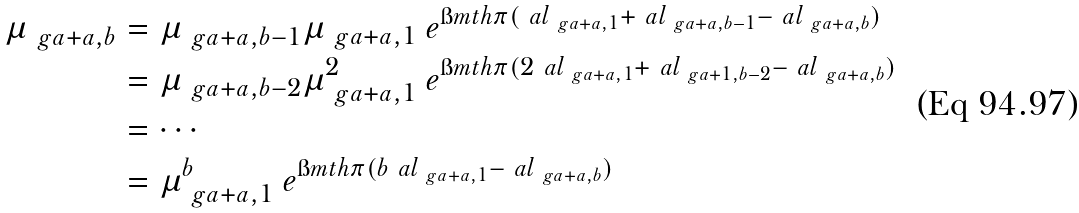Convert formula to latex. <formula><loc_0><loc_0><loc_500><loc_500>\mu _ { \ g a + a , b } & = \mu _ { \ g a + a , b - 1 } \mu _ { \ g a + a , 1 } \ e ^ { \i m t h \pi ( \ a l _ { \ g a + a , 1 } + \ a l _ { \ g a + a , b - 1 } - \ a l _ { \ g a + a , b } ) } \\ & = \mu _ { \ g a + a , b - 2 } \mu ^ { 2 } _ { \ g a + a , 1 } \ e ^ { \i m t h \pi ( 2 \ a l _ { \ g a + a , 1 } + \ a l _ { \ g a + 1 , b - 2 } - \ a l _ { \ g a + a , b } ) } \\ & = \cdots \\ & = \mu ^ { b } _ { \ g a + a , 1 } \ e ^ { \i m t h \pi ( b \ a l _ { \ g a + a , 1 } - \ a l _ { \ g a + a , b } ) }</formula> 